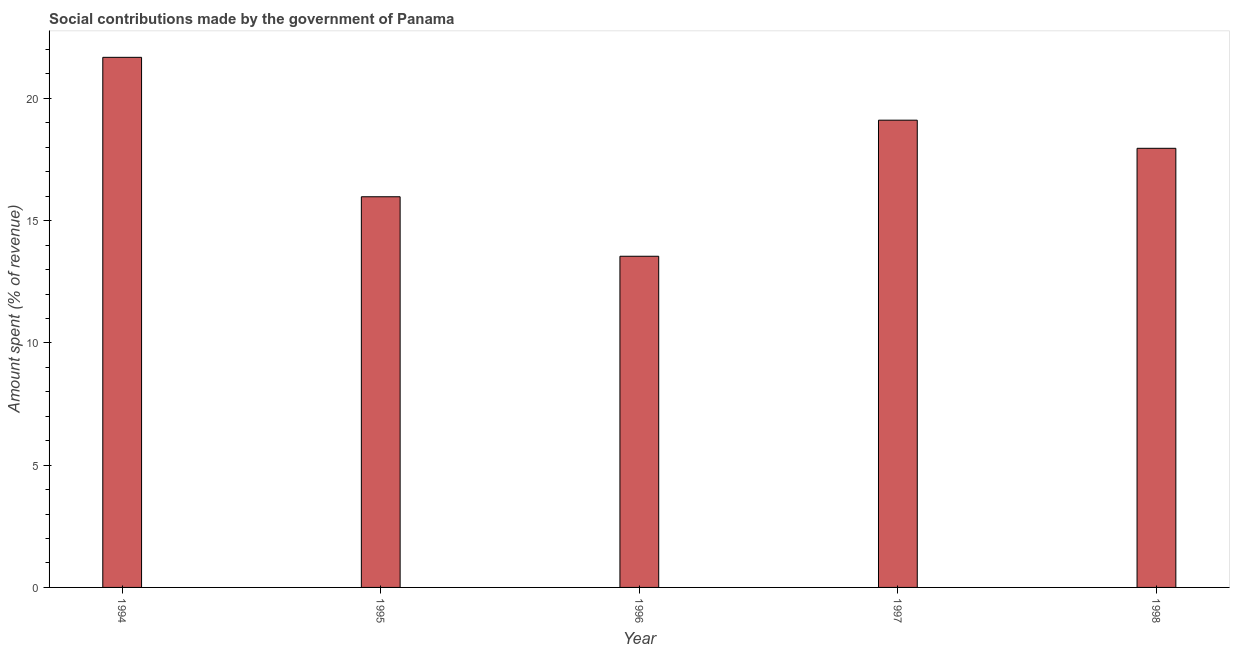Does the graph contain any zero values?
Make the answer very short. No. Does the graph contain grids?
Give a very brief answer. No. What is the title of the graph?
Ensure brevity in your answer.  Social contributions made by the government of Panama. What is the label or title of the Y-axis?
Your answer should be very brief. Amount spent (% of revenue). What is the amount spent in making social contributions in 1998?
Give a very brief answer. 17.96. Across all years, what is the maximum amount spent in making social contributions?
Ensure brevity in your answer.  21.68. Across all years, what is the minimum amount spent in making social contributions?
Provide a short and direct response. 13.54. In which year was the amount spent in making social contributions minimum?
Ensure brevity in your answer.  1996. What is the sum of the amount spent in making social contributions?
Offer a very short reply. 88.27. What is the difference between the amount spent in making social contributions in 1994 and 1996?
Provide a short and direct response. 8.14. What is the average amount spent in making social contributions per year?
Provide a short and direct response. 17.65. What is the median amount spent in making social contributions?
Your answer should be very brief. 17.96. Do a majority of the years between 1997 and 1996 (inclusive) have amount spent in making social contributions greater than 6 %?
Your response must be concise. No. What is the ratio of the amount spent in making social contributions in 1995 to that in 1998?
Provide a succinct answer. 0.89. What is the difference between the highest and the second highest amount spent in making social contributions?
Provide a short and direct response. 2.57. What is the difference between the highest and the lowest amount spent in making social contributions?
Your answer should be very brief. 8.14. How many bars are there?
Offer a terse response. 5. Are all the bars in the graph horizontal?
Make the answer very short. No. How many years are there in the graph?
Your answer should be very brief. 5. What is the difference between two consecutive major ticks on the Y-axis?
Your response must be concise. 5. What is the Amount spent (% of revenue) in 1994?
Your answer should be compact. 21.68. What is the Amount spent (% of revenue) in 1995?
Your response must be concise. 15.98. What is the Amount spent (% of revenue) in 1996?
Offer a very short reply. 13.54. What is the Amount spent (% of revenue) of 1997?
Make the answer very short. 19.11. What is the Amount spent (% of revenue) of 1998?
Make the answer very short. 17.96. What is the difference between the Amount spent (% of revenue) in 1994 and 1995?
Make the answer very short. 5.7. What is the difference between the Amount spent (% of revenue) in 1994 and 1996?
Offer a very short reply. 8.14. What is the difference between the Amount spent (% of revenue) in 1994 and 1997?
Offer a very short reply. 2.57. What is the difference between the Amount spent (% of revenue) in 1994 and 1998?
Provide a succinct answer. 3.72. What is the difference between the Amount spent (% of revenue) in 1995 and 1996?
Give a very brief answer. 2.43. What is the difference between the Amount spent (% of revenue) in 1995 and 1997?
Give a very brief answer. -3.13. What is the difference between the Amount spent (% of revenue) in 1995 and 1998?
Keep it short and to the point. -1.98. What is the difference between the Amount spent (% of revenue) in 1996 and 1997?
Provide a succinct answer. -5.57. What is the difference between the Amount spent (% of revenue) in 1996 and 1998?
Provide a short and direct response. -4.42. What is the difference between the Amount spent (% of revenue) in 1997 and 1998?
Provide a short and direct response. 1.15. What is the ratio of the Amount spent (% of revenue) in 1994 to that in 1995?
Your answer should be very brief. 1.36. What is the ratio of the Amount spent (% of revenue) in 1994 to that in 1996?
Give a very brief answer. 1.6. What is the ratio of the Amount spent (% of revenue) in 1994 to that in 1997?
Ensure brevity in your answer.  1.14. What is the ratio of the Amount spent (% of revenue) in 1994 to that in 1998?
Give a very brief answer. 1.21. What is the ratio of the Amount spent (% of revenue) in 1995 to that in 1996?
Give a very brief answer. 1.18. What is the ratio of the Amount spent (% of revenue) in 1995 to that in 1997?
Keep it short and to the point. 0.84. What is the ratio of the Amount spent (% of revenue) in 1995 to that in 1998?
Make the answer very short. 0.89. What is the ratio of the Amount spent (% of revenue) in 1996 to that in 1997?
Offer a very short reply. 0.71. What is the ratio of the Amount spent (% of revenue) in 1996 to that in 1998?
Ensure brevity in your answer.  0.75. What is the ratio of the Amount spent (% of revenue) in 1997 to that in 1998?
Provide a short and direct response. 1.06. 